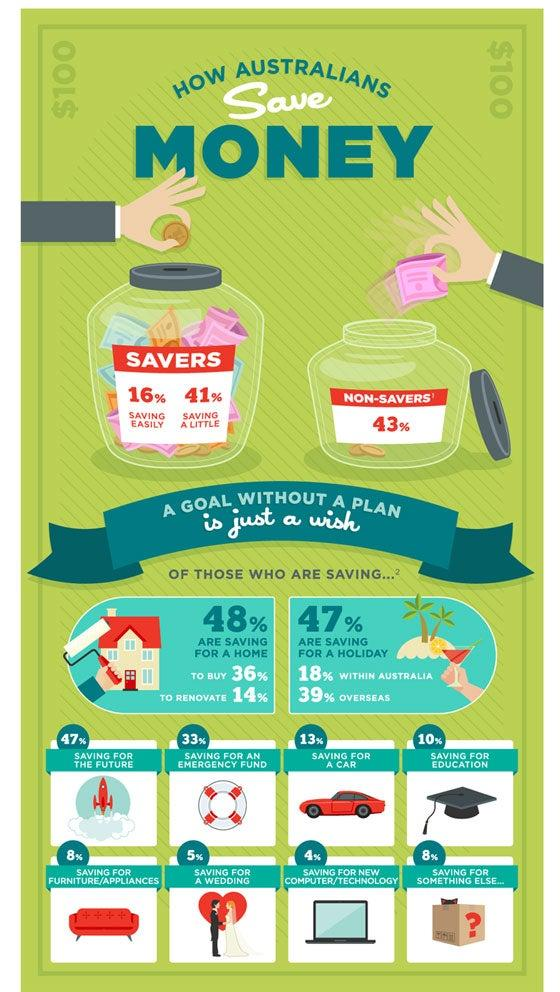Specify some key components in this picture. According to a recent survey, 16% of Australians are finding it easy to save money. According to a recent survey, 36% of Australians are currently saving money with the goal of purchasing a house. According to a recent survey, 33% of Australians are actively saving money for an emergency fund. The activity of saving for a new computer or technology is considered to be the least savings-oriented activity among Australians, as it is often viewed as a luxury expenditure rather than a necessary investment for future financial stability. According to a recent survey, 43% of Australians do not save money. 